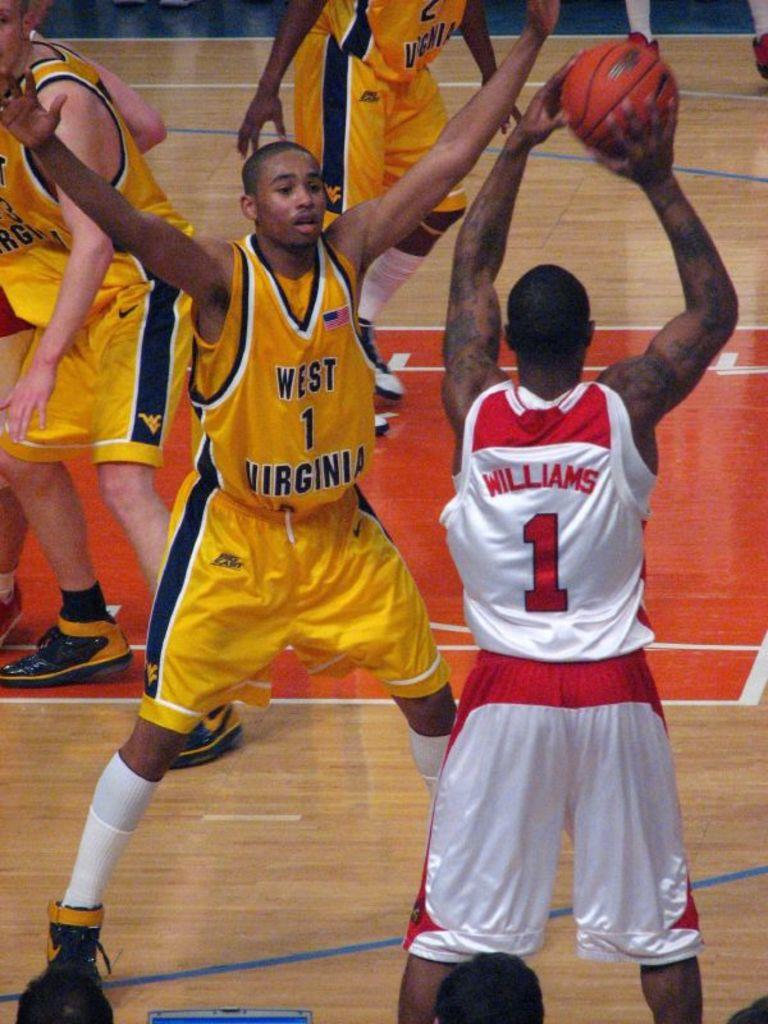Provide a one-sentence caption for the provided image. Williams, in the red and white number 1 jersey, looks for someone to whom he can pass the ball. 